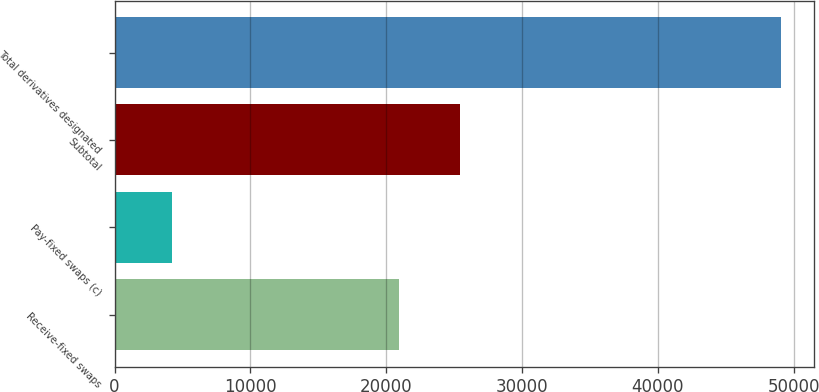Convert chart to OTSL. <chart><loc_0><loc_0><loc_500><loc_500><bar_chart><fcel>Receive-fixed swaps<fcel>Pay-fixed swaps (c)<fcel>Subtotal<fcel>Total derivatives designated<nl><fcel>20930<fcel>4233<fcel>25412.8<fcel>49061<nl></chart> 